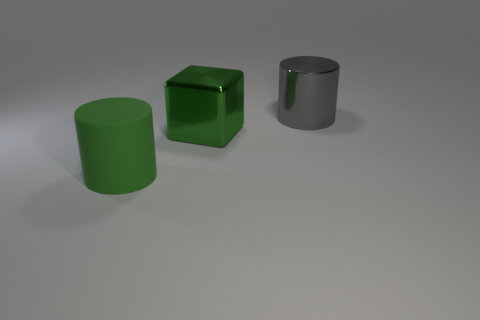What material is the large gray object?
Give a very brief answer. Metal. The big cylinder that is right of the green object in front of the green object to the right of the green matte thing is what color?
Ensure brevity in your answer.  Gray. There is another large thing that is the same shape as the gray object; what is it made of?
Your answer should be very brief. Rubber. What number of shiny things are the same size as the gray shiny cylinder?
Your answer should be compact. 1. How many large blue metal blocks are there?
Offer a very short reply. 0. Is the green cube made of the same material as the large cylinder to the right of the green rubber cylinder?
Offer a terse response. Yes. How many green things are large cubes or big matte objects?
Offer a terse response. 2. What is the size of the block that is the same material as the gray thing?
Make the answer very short. Large. What number of other objects have the same shape as the large green rubber thing?
Your response must be concise. 1. Is the number of things behind the matte cylinder greater than the number of green rubber things that are in front of the large green shiny object?
Your answer should be compact. Yes. 